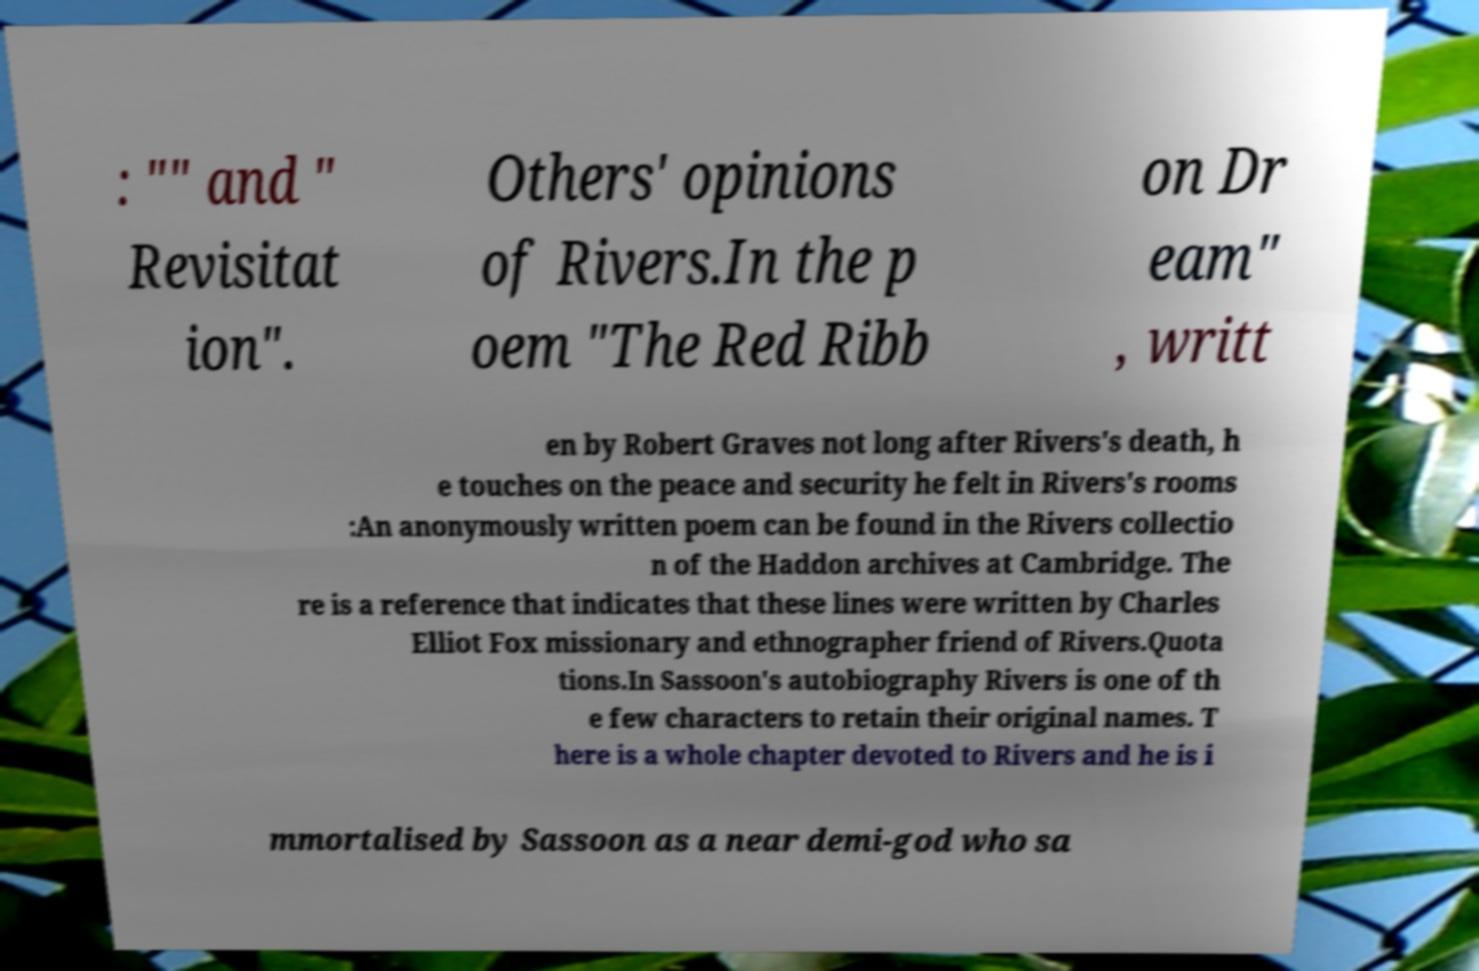Can you read and provide the text displayed in the image?This photo seems to have some interesting text. Can you extract and type it out for me? : "" and " Revisitat ion". Others' opinions of Rivers.In the p oem "The Red Ribb on Dr eam" , writt en by Robert Graves not long after Rivers's death, h e touches on the peace and security he felt in Rivers's rooms :An anonymously written poem can be found in the Rivers collectio n of the Haddon archives at Cambridge. The re is a reference that indicates that these lines were written by Charles Elliot Fox missionary and ethnographer friend of Rivers.Quota tions.In Sassoon's autobiography Rivers is one of th e few characters to retain their original names. T here is a whole chapter devoted to Rivers and he is i mmortalised by Sassoon as a near demi-god who sa 